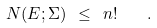<formula> <loc_0><loc_0><loc_500><loc_500>N ( E ; \Sigma ) \ \leq \ n ! \quad .</formula> 